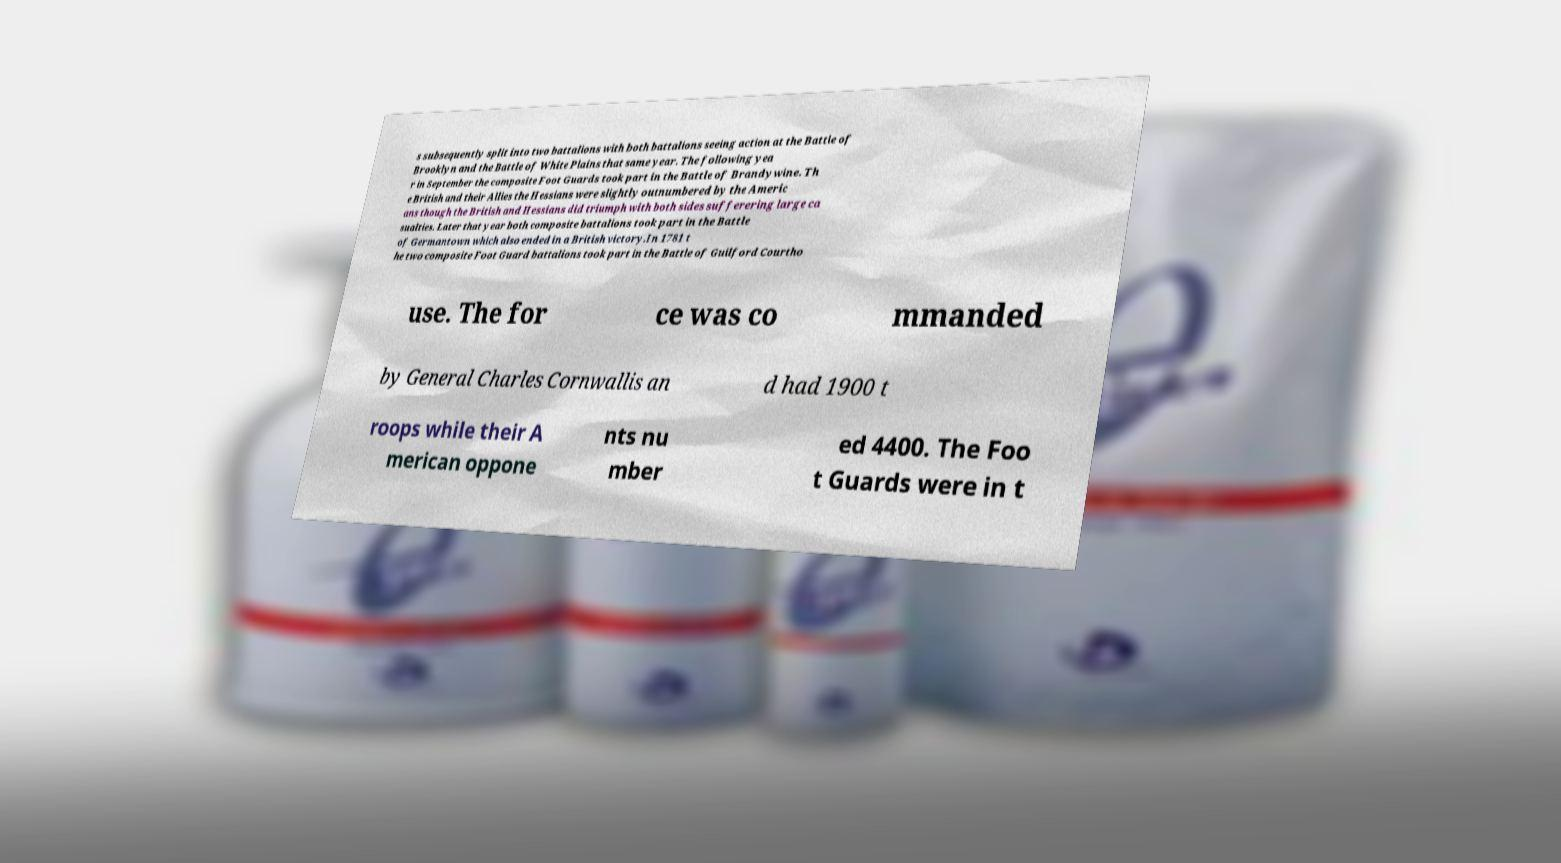Could you extract and type out the text from this image? s subsequently split into two battalions with both battalions seeing action at the Battle of Brooklyn and the Battle of White Plains that same year. The following yea r in September the composite Foot Guards took part in the Battle of Brandywine. Th e British and their Allies the Hessians were slightly outnumbered by the Americ ans though the British and Hessians did triumph with both sides sufferering large ca sualties. Later that year both composite battalions took part in the Battle of Germantown which also ended in a British victory.In 1781 t he two composite Foot Guard battalions took part in the Battle of Guilford Courtho use. The for ce was co mmanded by General Charles Cornwallis an d had 1900 t roops while their A merican oppone nts nu mber ed 4400. The Foo t Guards were in t 